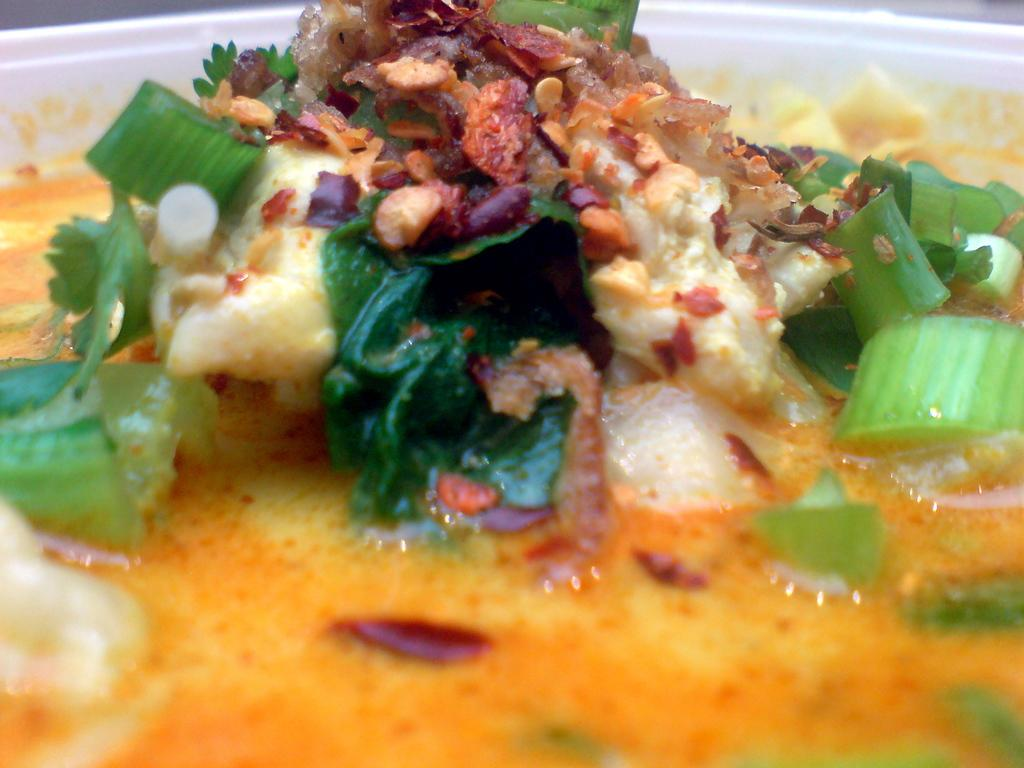What is present on the serving plate in the image? There is food on the serving plate in the image. What type of car is parked next to the serving plate in the image? There is no car present in the image; it only features a serving plate with food. 